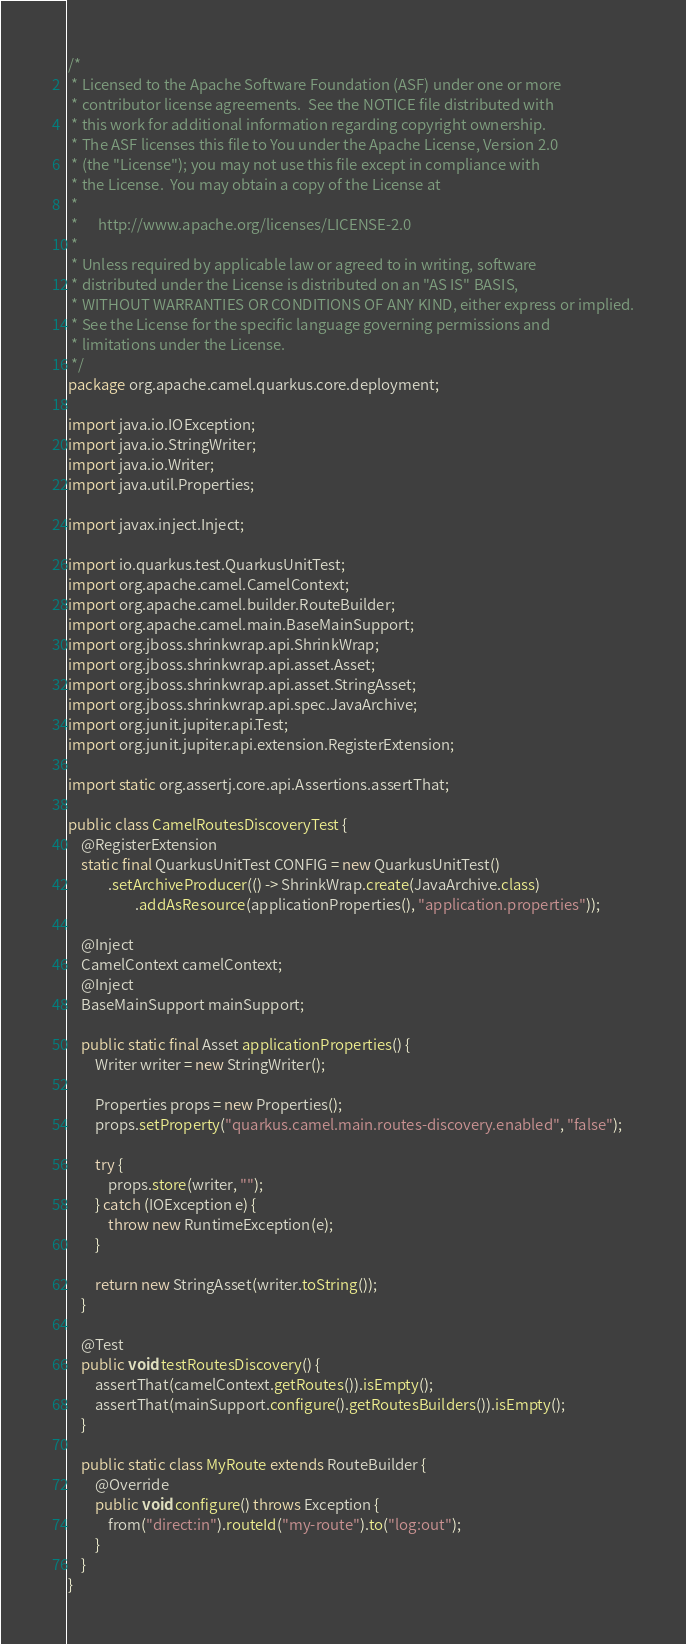<code> <loc_0><loc_0><loc_500><loc_500><_Java_>/*
 * Licensed to the Apache Software Foundation (ASF) under one or more
 * contributor license agreements.  See the NOTICE file distributed with
 * this work for additional information regarding copyright ownership.
 * The ASF licenses this file to You under the Apache License, Version 2.0
 * (the "License"); you may not use this file except in compliance with
 * the License.  You may obtain a copy of the License at
 *
 *      http://www.apache.org/licenses/LICENSE-2.0
 *
 * Unless required by applicable law or agreed to in writing, software
 * distributed under the License is distributed on an "AS IS" BASIS,
 * WITHOUT WARRANTIES OR CONDITIONS OF ANY KIND, either express or implied.
 * See the License for the specific language governing permissions and
 * limitations under the License.
 */
package org.apache.camel.quarkus.core.deployment;

import java.io.IOException;
import java.io.StringWriter;
import java.io.Writer;
import java.util.Properties;

import javax.inject.Inject;

import io.quarkus.test.QuarkusUnitTest;
import org.apache.camel.CamelContext;
import org.apache.camel.builder.RouteBuilder;
import org.apache.camel.main.BaseMainSupport;
import org.jboss.shrinkwrap.api.ShrinkWrap;
import org.jboss.shrinkwrap.api.asset.Asset;
import org.jboss.shrinkwrap.api.asset.StringAsset;
import org.jboss.shrinkwrap.api.spec.JavaArchive;
import org.junit.jupiter.api.Test;
import org.junit.jupiter.api.extension.RegisterExtension;

import static org.assertj.core.api.Assertions.assertThat;

public class CamelRoutesDiscoveryTest {
    @RegisterExtension
    static final QuarkusUnitTest CONFIG = new QuarkusUnitTest()
            .setArchiveProducer(() -> ShrinkWrap.create(JavaArchive.class)
                    .addAsResource(applicationProperties(), "application.properties"));

    @Inject
    CamelContext camelContext;
    @Inject
    BaseMainSupport mainSupport;

    public static final Asset applicationProperties() {
        Writer writer = new StringWriter();

        Properties props = new Properties();
        props.setProperty("quarkus.camel.main.routes-discovery.enabled", "false");

        try {
            props.store(writer, "");
        } catch (IOException e) {
            throw new RuntimeException(e);
        }

        return new StringAsset(writer.toString());
    }

    @Test
    public void testRoutesDiscovery() {
        assertThat(camelContext.getRoutes()).isEmpty();
        assertThat(mainSupport.configure().getRoutesBuilders()).isEmpty();
    }

    public static class MyRoute extends RouteBuilder {
        @Override
        public void configure() throws Exception {
            from("direct:in").routeId("my-route").to("log:out");
        }
    }
}
</code> 